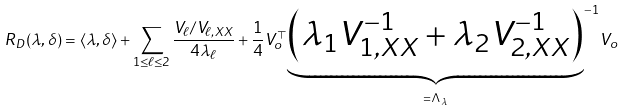Convert formula to latex. <formula><loc_0><loc_0><loc_500><loc_500>R _ { D } ( \lambda , \delta ) = \langle \lambda , \delta \rangle + \sum _ { 1 \leq \ell \leq 2 } \frac { V _ { \ell } / V _ { \ell , X X } } { 4 \lambda _ { \ell } } + \frac { 1 } { 4 } V _ { o } ^ { \top } { \underbrace { \left ( \lambda _ { 1 } V _ { 1 , X X } ^ { - 1 } + \lambda _ { 2 } V _ { 2 , X X } ^ { - 1 } \right ) } _ { = \Lambda _ { \lambda } } } ^ { - 1 } V _ { o }</formula> 